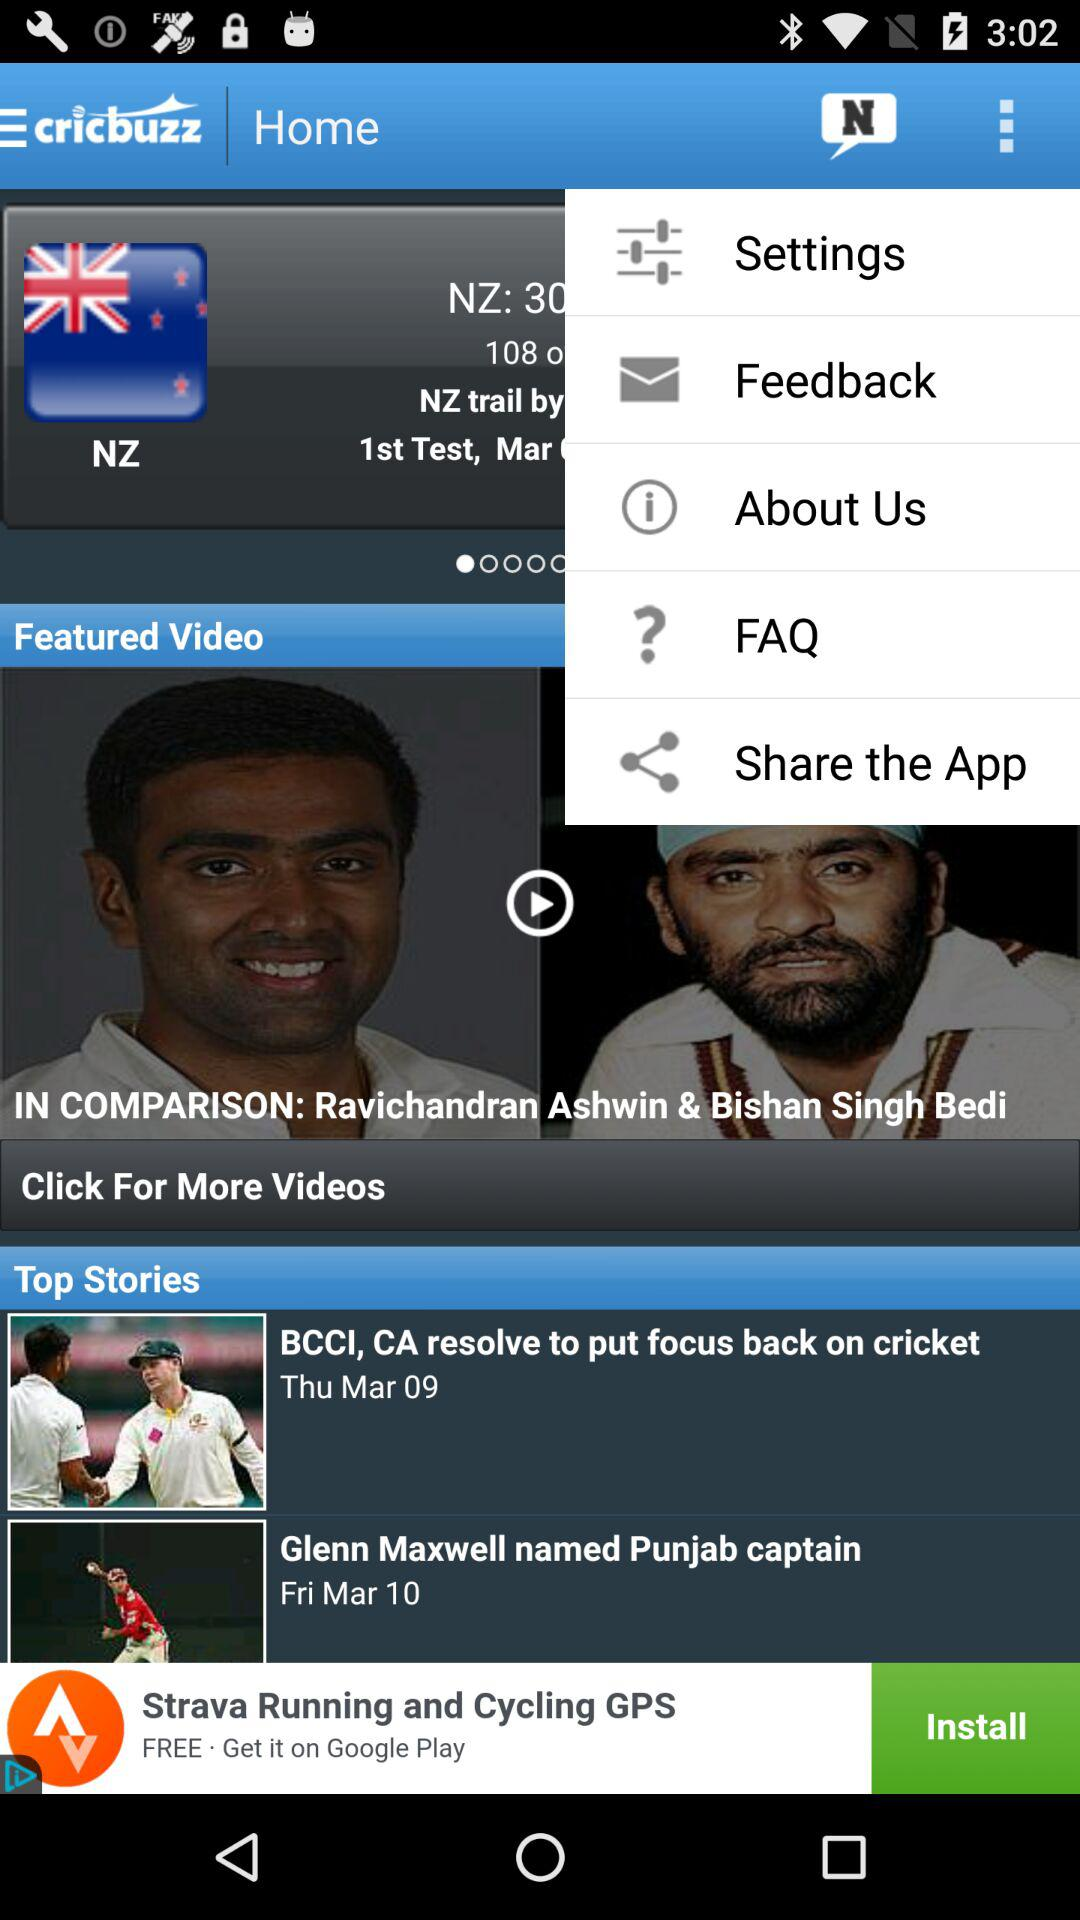How many more days until Glenn Maxwell is named Punjab captain?
Answer the question using a single word or phrase. 1 